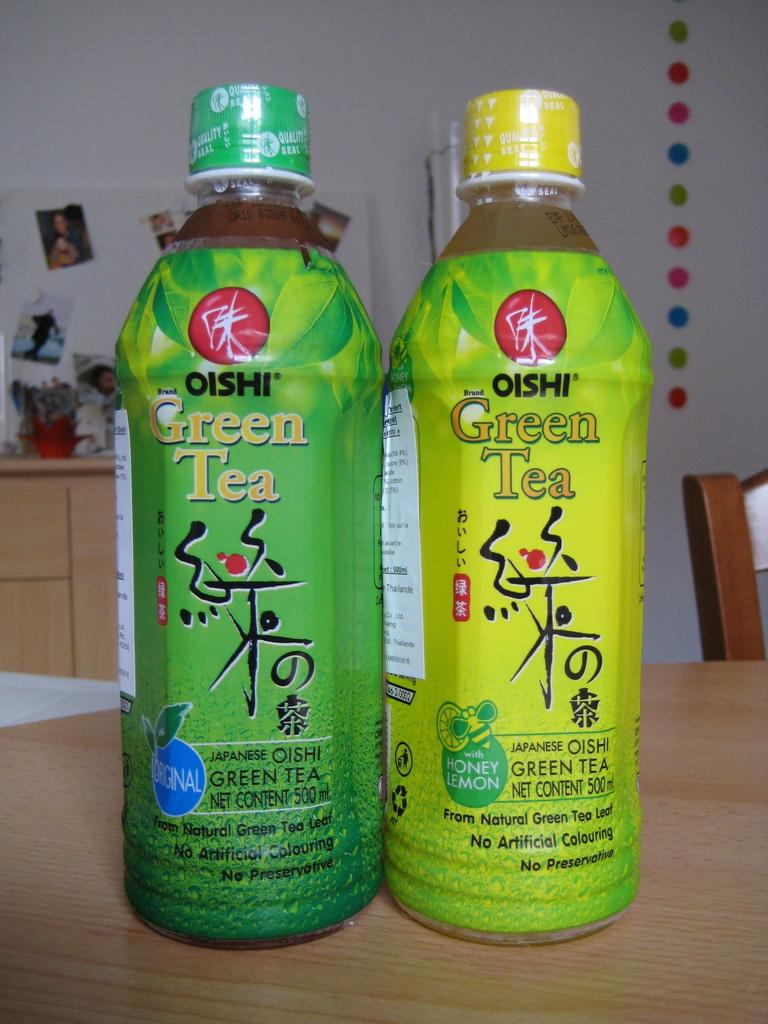<image>
Summarize the visual content of the image. Two bottles of Oishi green tea have different shades of green for their labels. 